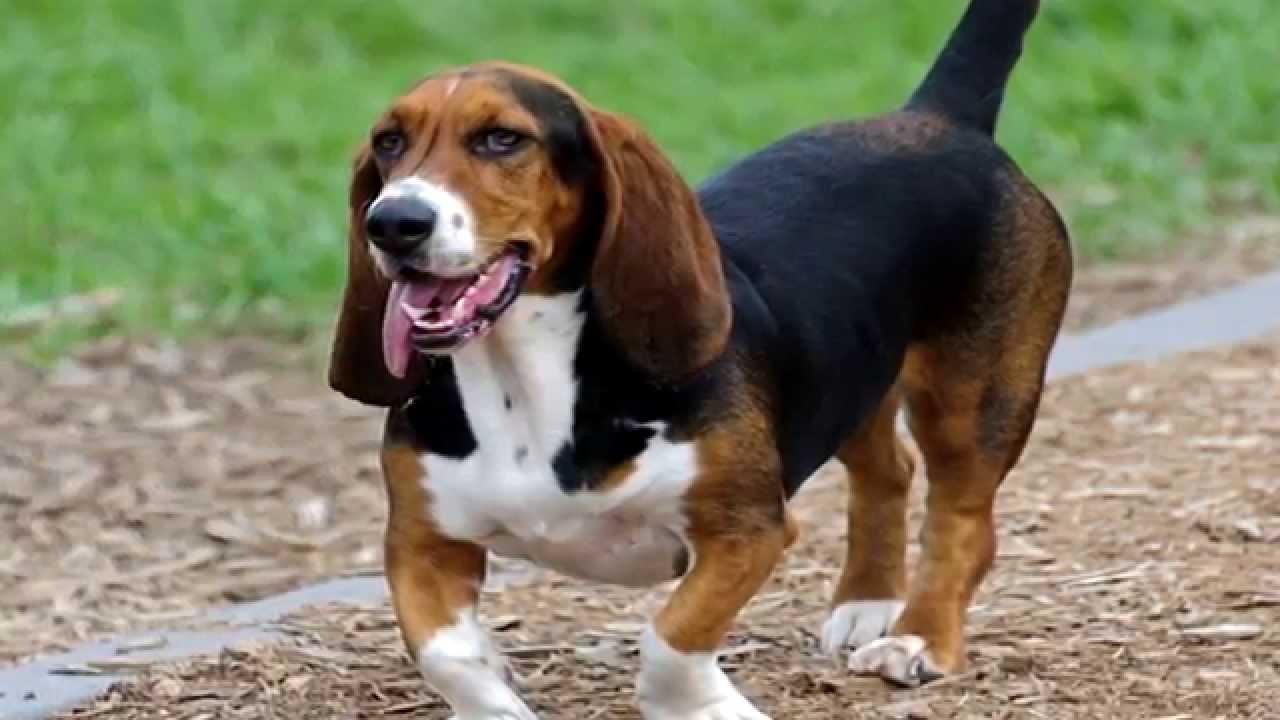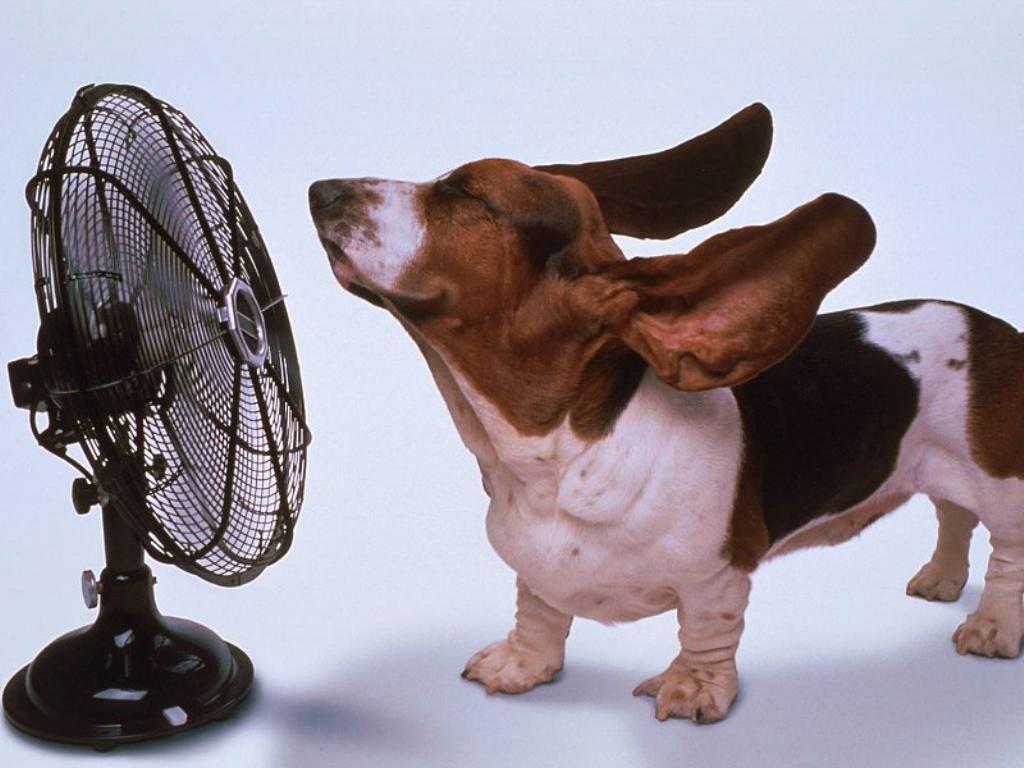The first image is the image on the left, the second image is the image on the right. For the images shown, is this caption "There are no more than two dogs." true? Answer yes or no. Yes. The first image is the image on the left, the second image is the image on the right. Evaluate the accuracy of this statement regarding the images: "Each image contains the same number of animals and contains more than one animal.". Is it true? Answer yes or no. No. 